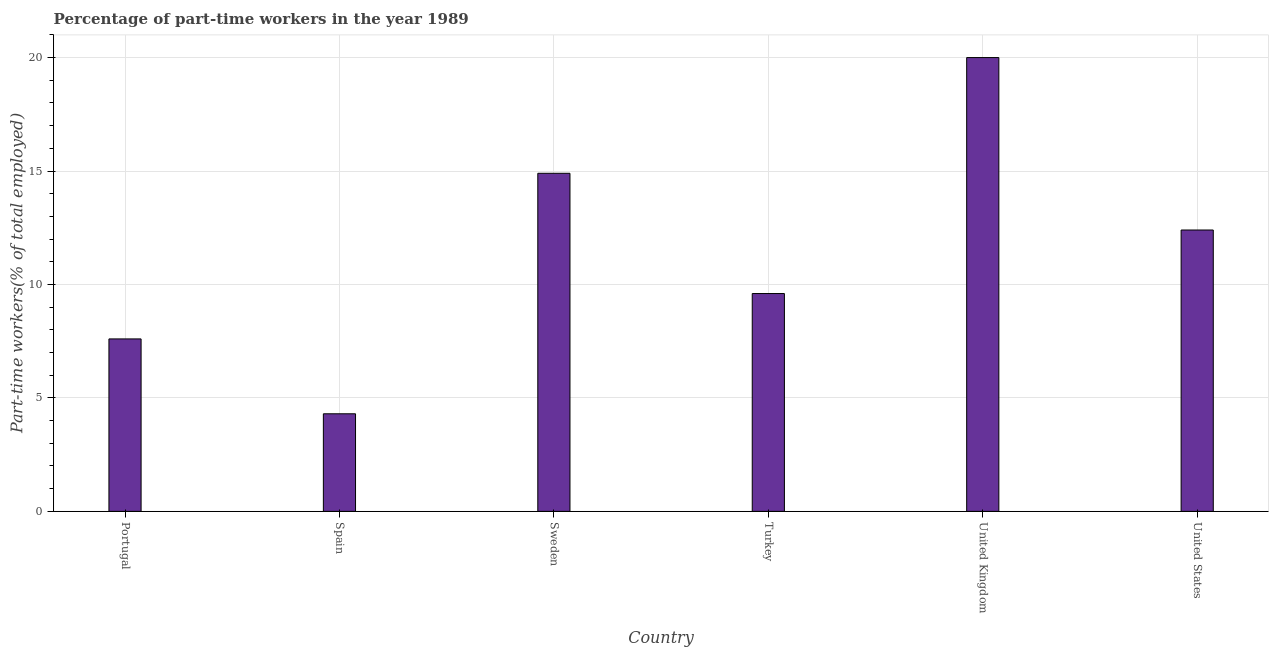Does the graph contain any zero values?
Provide a short and direct response. No. What is the title of the graph?
Your answer should be very brief. Percentage of part-time workers in the year 1989. What is the label or title of the Y-axis?
Your answer should be compact. Part-time workers(% of total employed). What is the percentage of part-time workers in United States?
Provide a succinct answer. 12.4. Across all countries, what is the maximum percentage of part-time workers?
Provide a succinct answer. 20. Across all countries, what is the minimum percentage of part-time workers?
Your answer should be very brief. 4.3. In which country was the percentage of part-time workers maximum?
Offer a terse response. United Kingdom. What is the sum of the percentage of part-time workers?
Provide a short and direct response. 68.8. What is the difference between the percentage of part-time workers in Sweden and United States?
Your answer should be compact. 2.5. What is the average percentage of part-time workers per country?
Give a very brief answer. 11.47. What is the median percentage of part-time workers?
Your answer should be very brief. 11. In how many countries, is the percentage of part-time workers greater than 18 %?
Ensure brevity in your answer.  1. What is the ratio of the percentage of part-time workers in Spain to that in Turkey?
Make the answer very short. 0.45. Is the difference between the percentage of part-time workers in Portugal and United States greater than the difference between any two countries?
Make the answer very short. No. What is the difference between the highest and the second highest percentage of part-time workers?
Your answer should be very brief. 5.1. Is the sum of the percentage of part-time workers in Turkey and United States greater than the maximum percentage of part-time workers across all countries?
Your response must be concise. Yes. What is the difference between the highest and the lowest percentage of part-time workers?
Ensure brevity in your answer.  15.7. Are all the bars in the graph horizontal?
Your answer should be compact. No. How many countries are there in the graph?
Make the answer very short. 6. What is the difference between two consecutive major ticks on the Y-axis?
Your answer should be compact. 5. Are the values on the major ticks of Y-axis written in scientific E-notation?
Provide a succinct answer. No. What is the Part-time workers(% of total employed) of Portugal?
Your answer should be very brief. 7.6. What is the Part-time workers(% of total employed) in Spain?
Give a very brief answer. 4.3. What is the Part-time workers(% of total employed) of Sweden?
Offer a terse response. 14.9. What is the Part-time workers(% of total employed) in Turkey?
Provide a succinct answer. 9.6. What is the Part-time workers(% of total employed) in United States?
Offer a very short reply. 12.4. What is the difference between the Part-time workers(% of total employed) in Spain and United Kingdom?
Keep it short and to the point. -15.7. What is the difference between the Part-time workers(% of total employed) in Spain and United States?
Provide a short and direct response. -8.1. What is the difference between the Part-time workers(% of total employed) in Sweden and Turkey?
Offer a terse response. 5.3. What is the difference between the Part-time workers(% of total employed) in Turkey and United Kingdom?
Make the answer very short. -10.4. What is the ratio of the Part-time workers(% of total employed) in Portugal to that in Spain?
Keep it short and to the point. 1.77. What is the ratio of the Part-time workers(% of total employed) in Portugal to that in Sweden?
Make the answer very short. 0.51. What is the ratio of the Part-time workers(% of total employed) in Portugal to that in Turkey?
Ensure brevity in your answer.  0.79. What is the ratio of the Part-time workers(% of total employed) in Portugal to that in United Kingdom?
Your answer should be very brief. 0.38. What is the ratio of the Part-time workers(% of total employed) in Portugal to that in United States?
Your response must be concise. 0.61. What is the ratio of the Part-time workers(% of total employed) in Spain to that in Sweden?
Keep it short and to the point. 0.29. What is the ratio of the Part-time workers(% of total employed) in Spain to that in Turkey?
Provide a succinct answer. 0.45. What is the ratio of the Part-time workers(% of total employed) in Spain to that in United Kingdom?
Offer a terse response. 0.21. What is the ratio of the Part-time workers(% of total employed) in Spain to that in United States?
Offer a terse response. 0.35. What is the ratio of the Part-time workers(% of total employed) in Sweden to that in Turkey?
Your answer should be compact. 1.55. What is the ratio of the Part-time workers(% of total employed) in Sweden to that in United Kingdom?
Your response must be concise. 0.74. What is the ratio of the Part-time workers(% of total employed) in Sweden to that in United States?
Provide a short and direct response. 1.2. What is the ratio of the Part-time workers(% of total employed) in Turkey to that in United Kingdom?
Your answer should be compact. 0.48. What is the ratio of the Part-time workers(% of total employed) in Turkey to that in United States?
Offer a very short reply. 0.77. What is the ratio of the Part-time workers(% of total employed) in United Kingdom to that in United States?
Ensure brevity in your answer.  1.61. 